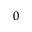<formula> <loc_0><loc_0><loc_500><loc_500>0 ^ { \circ }</formula> 